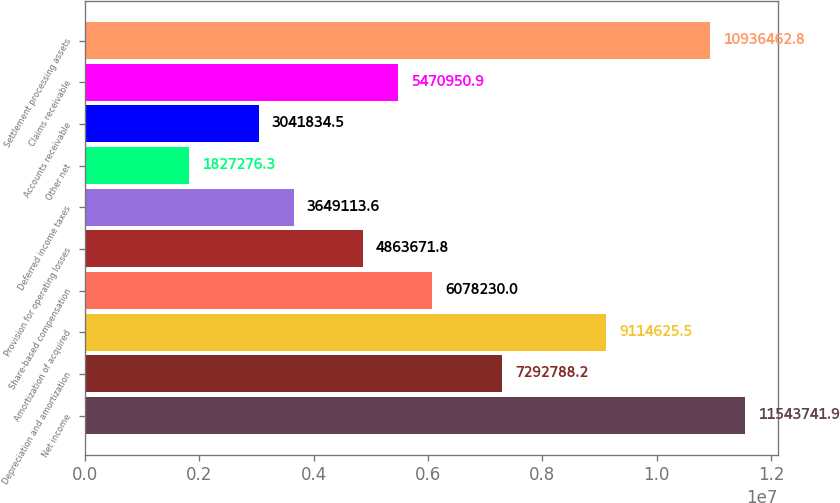Convert chart. <chart><loc_0><loc_0><loc_500><loc_500><bar_chart><fcel>Net income<fcel>Depreciation and amortization<fcel>Amortization of acquired<fcel>Share-based compensation<fcel>Provision for operating losses<fcel>Deferred income taxes<fcel>Other net<fcel>Accounts receivable<fcel>Claims receivable<fcel>Settlement processing assets<nl><fcel>1.15437e+07<fcel>7.29279e+06<fcel>9.11463e+06<fcel>6.07823e+06<fcel>4.86367e+06<fcel>3.64911e+06<fcel>1.82728e+06<fcel>3.04183e+06<fcel>5.47095e+06<fcel>1.09365e+07<nl></chart> 